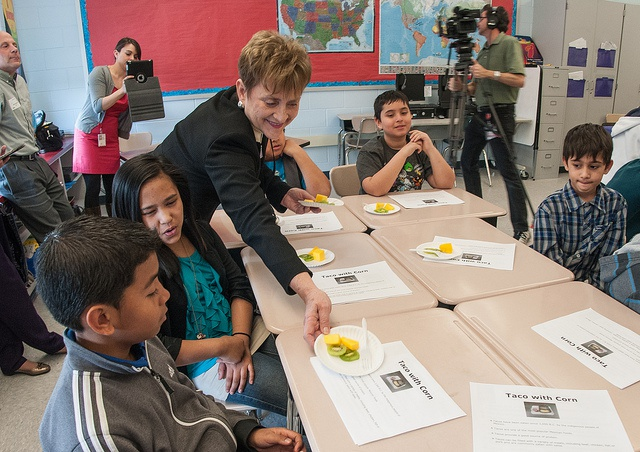Describe the objects in this image and their specific colors. I can see people in darkgray, black, gray, and maroon tones, dining table in darkgray, lightgray, and tan tones, people in darkgray, black, brown, maroon, and tan tones, people in darkgray, black, teal, brown, and gray tones, and people in darkgray, black, gray, and navy tones in this image. 